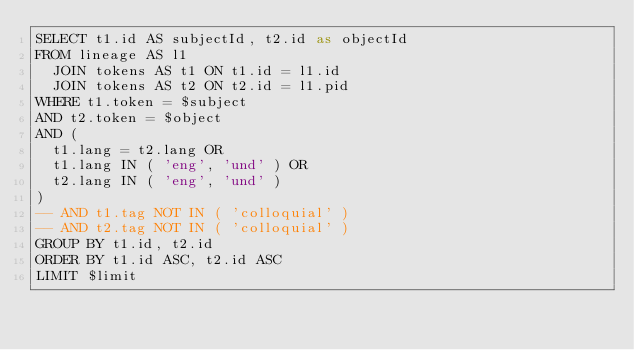<code> <loc_0><loc_0><loc_500><loc_500><_SQL_>SELECT t1.id AS subjectId, t2.id as objectId
FROM lineage AS l1
  JOIN tokens AS t1 ON t1.id = l1.id
  JOIN tokens AS t2 ON t2.id = l1.pid
WHERE t1.token = $subject
AND t2.token = $object
AND (
  t1.lang = t2.lang OR
  t1.lang IN ( 'eng', 'und' ) OR
  t2.lang IN ( 'eng', 'und' )
)
-- AND t1.tag NOT IN ( 'colloquial' )
-- AND t2.tag NOT IN ( 'colloquial' )
GROUP BY t1.id, t2.id
ORDER BY t1.id ASC, t2.id ASC
LIMIT $limit
</code> 